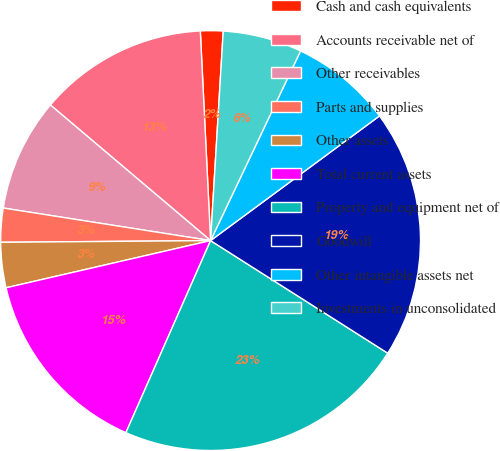Convert chart to OTSL. <chart><loc_0><loc_0><loc_500><loc_500><pie_chart><fcel>Cash and cash equivalents<fcel>Accounts receivable net of<fcel>Other receivables<fcel>Parts and supplies<fcel>Other assets<fcel>Total current assets<fcel>Property and equipment net of<fcel>Goodwill<fcel>Other intangible assets net<fcel>Investments in unconsolidated<nl><fcel>1.74%<fcel>13.04%<fcel>8.7%<fcel>2.61%<fcel>3.48%<fcel>14.78%<fcel>22.6%<fcel>19.13%<fcel>7.83%<fcel>6.09%<nl></chart> 